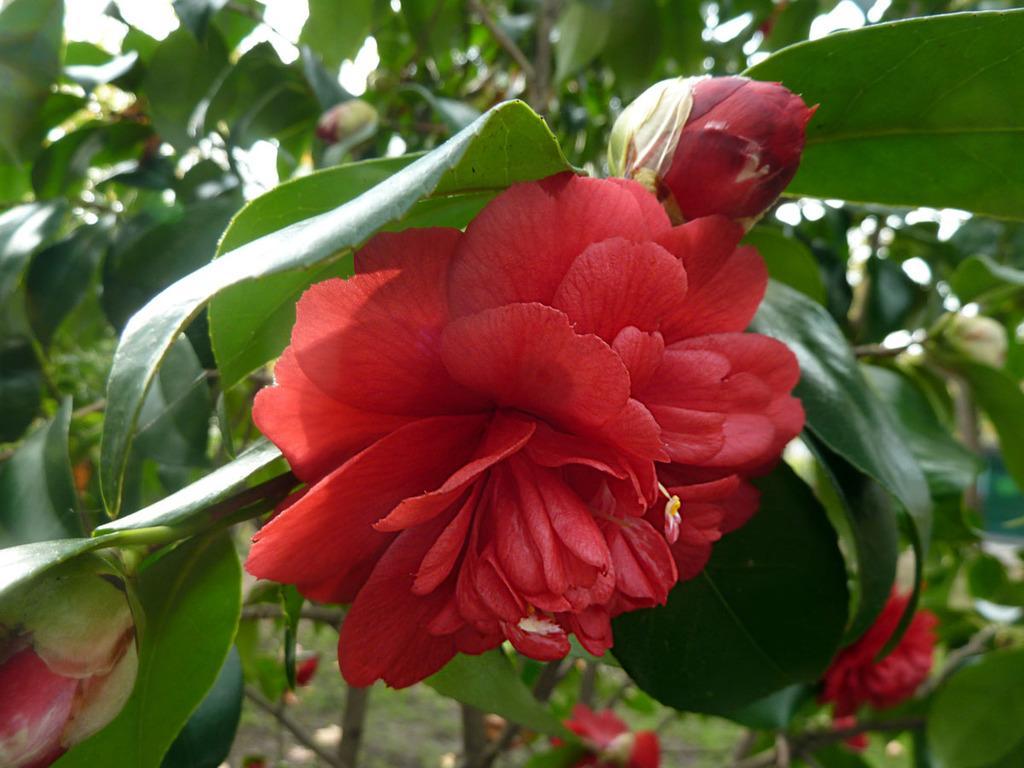Could you give a brief overview of what you see in this image? In this image, we can see some leaves, buds and flowers. 